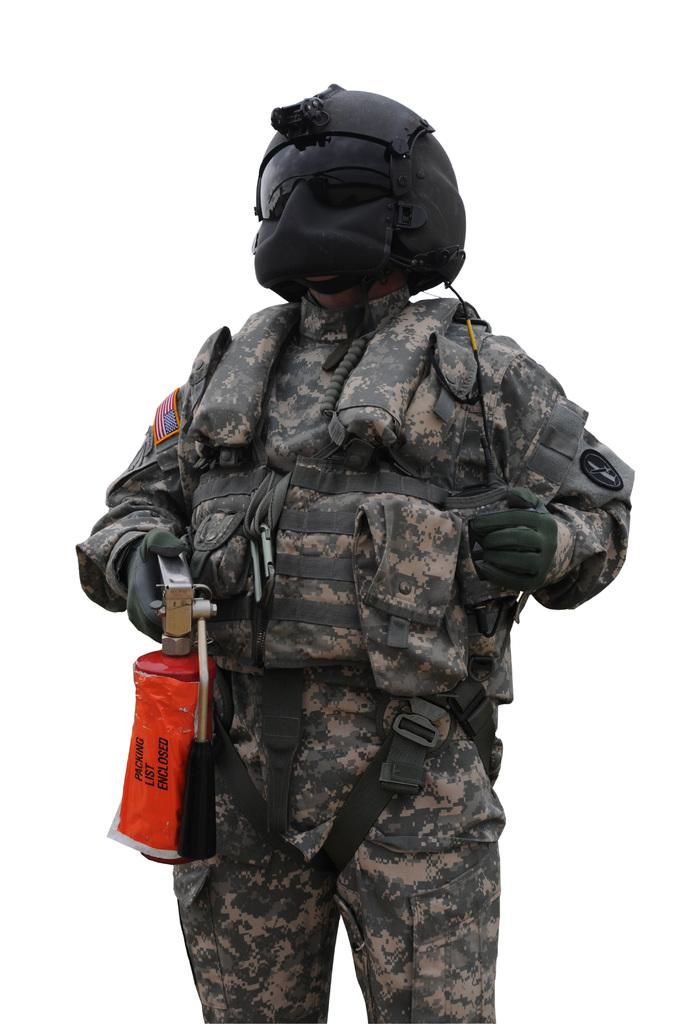What is the main subject of the image? There is a person in the image. What type of clothing is the person wearing? The person is wearing army clothes. What type of headgear is the person wearing? The person is wearing a black color helmet with a mask. What object is the person holding in the image? The person is holding a gas bottle. How many dogs are visible in the image? There are no dogs present in the image. What type of zephyr can be seen blowing through the person's hair in the image? There is no zephyr present in the image, and the person's hair is not visible due to the helmet and mask. 